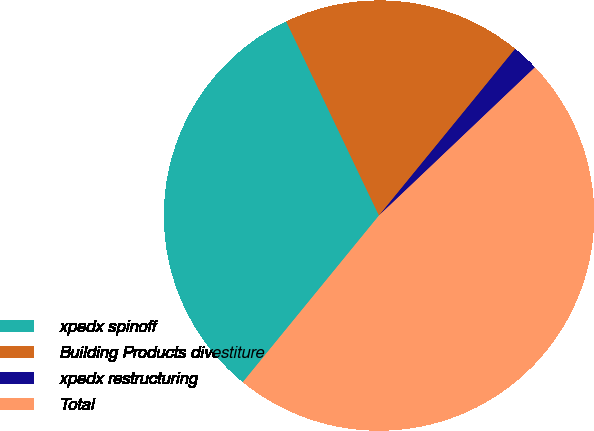Convert chart to OTSL. <chart><loc_0><loc_0><loc_500><loc_500><pie_chart><fcel>xpedx spinoff<fcel>Building Products divestiture<fcel>xpedx restructuring<fcel>Total<nl><fcel>32.0%<fcel>18.0%<fcel>2.0%<fcel>48.0%<nl></chart> 